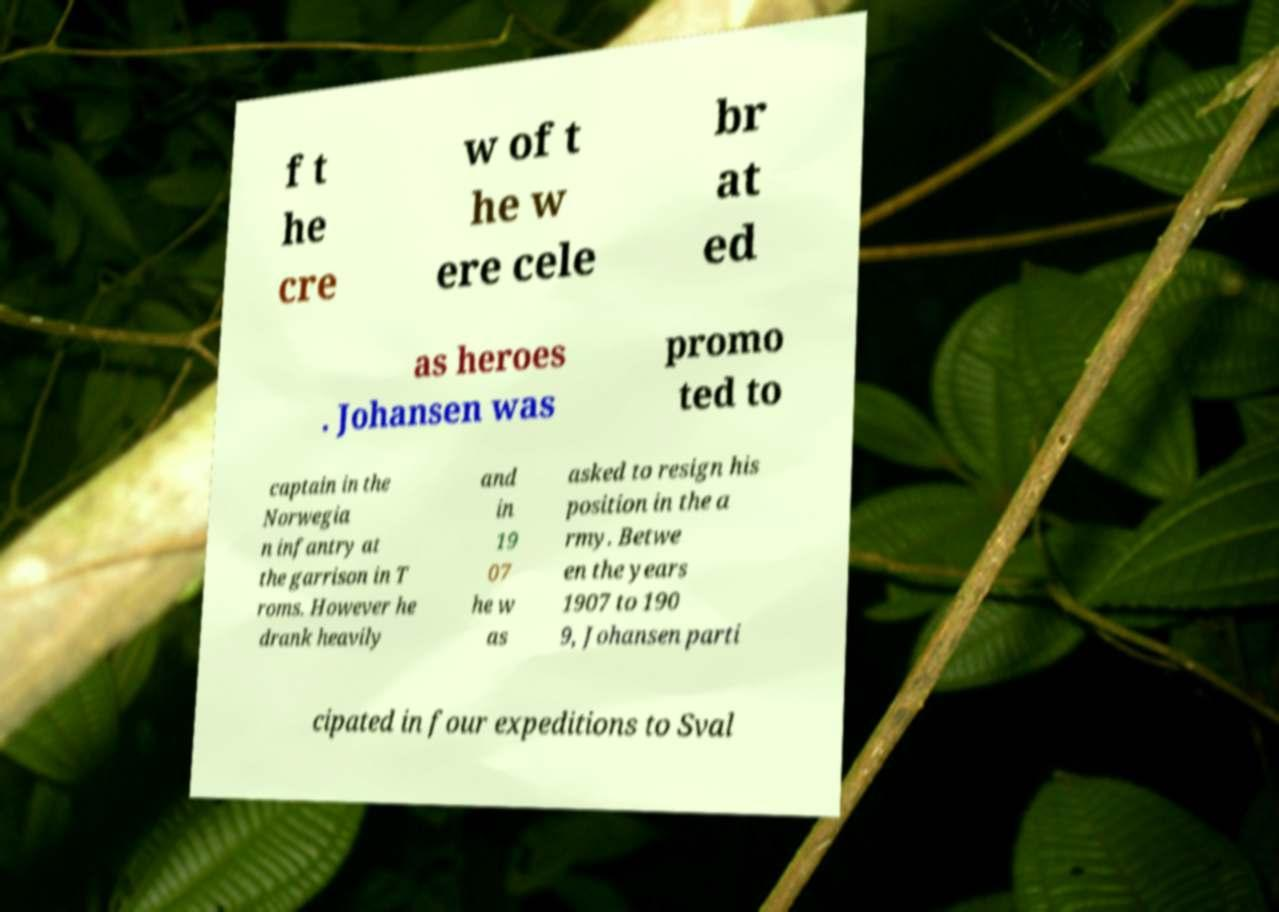Please identify and transcribe the text found in this image. f t he cre w of t he w ere cele br at ed as heroes . Johansen was promo ted to captain in the Norwegia n infantry at the garrison in T roms. However he drank heavily and in 19 07 he w as asked to resign his position in the a rmy. Betwe en the years 1907 to 190 9, Johansen parti cipated in four expeditions to Sval 